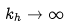Convert formula to latex. <formula><loc_0><loc_0><loc_500><loc_500>k _ { h } \rightarrow \infty</formula> 